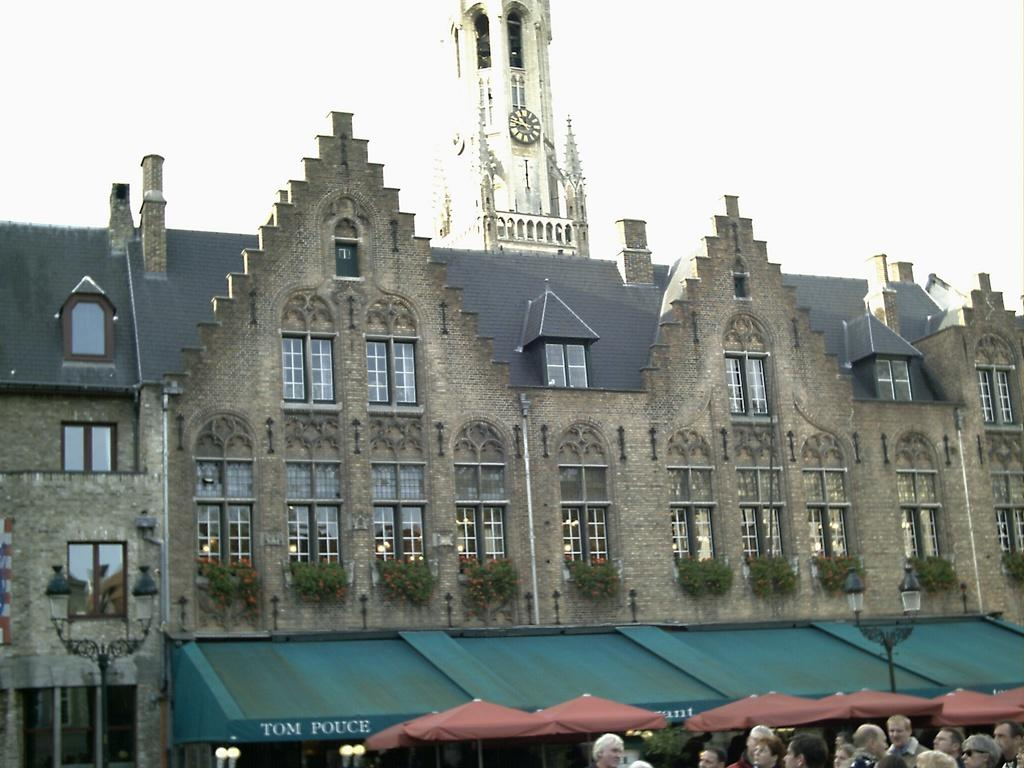What type of structures can be seen in the image? There are buildings in the image. What architectural features can be observed on the buildings? There are windows visible on the buildings. What other elements are present in the image? There are plants, people, and a clock in the image. What can be seen in the sky in the image? The sky is visible in the image. What type of judgment is the judge making in the image? There is no judge present in the image, so it is not possible to determine any judgments being made. 